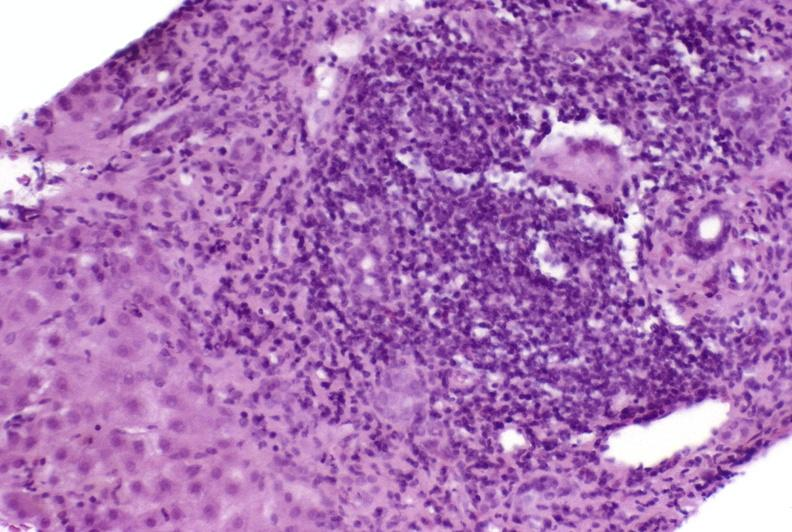does serous cystadenoma show autoimmune hepatitis?
Answer the question using a single word or phrase. No 